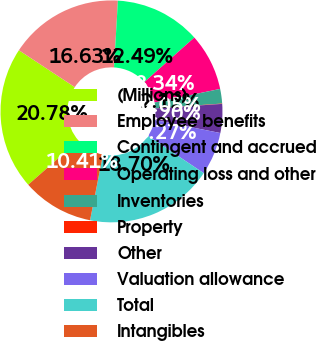<chart> <loc_0><loc_0><loc_500><loc_500><pie_chart><fcel>(Millions)<fcel>Employee benefits<fcel>Contingent and accrued<fcel>Operating loss and other<fcel>Inventories<fcel>Property<fcel>Other<fcel>Valuation allowance<fcel>Total<fcel>Intangibles<nl><fcel>20.78%<fcel>16.63%<fcel>12.49%<fcel>8.34%<fcel>2.12%<fcel>0.05%<fcel>4.2%<fcel>6.27%<fcel>18.7%<fcel>10.41%<nl></chart> 